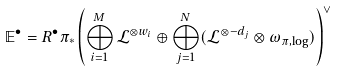<formula> <loc_0><loc_0><loc_500><loc_500>\mathbb { E } ^ { \bullet } = R ^ { \bullet } \pi _ { * } \left ( \bigoplus _ { i = 1 } ^ { M } \mathcal { L } ^ { \otimes w _ { i } } \oplus \bigoplus _ { j = 1 } ^ { N } ( \mathcal { L } ^ { \otimes - d _ { j } } \otimes \omega _ { \pi , \log } ) \right ) ^ { \vee }</formula> 